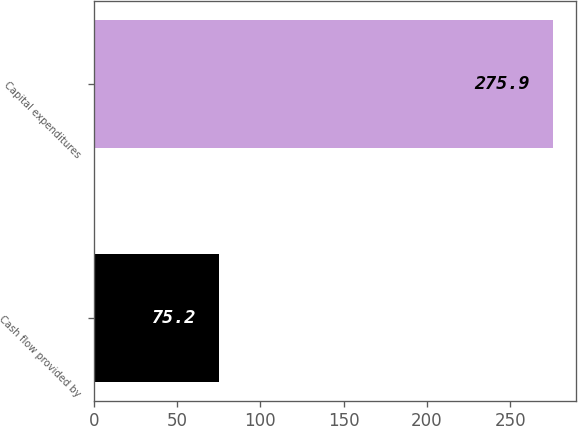<chart> <loc_0><loc_0><loc_500><loc_500><bar_chart><fcel>Cash flow provided by<fcel>Capital expenditures<nl><fcel>75.2<fcel>275.9<nl></chart> 